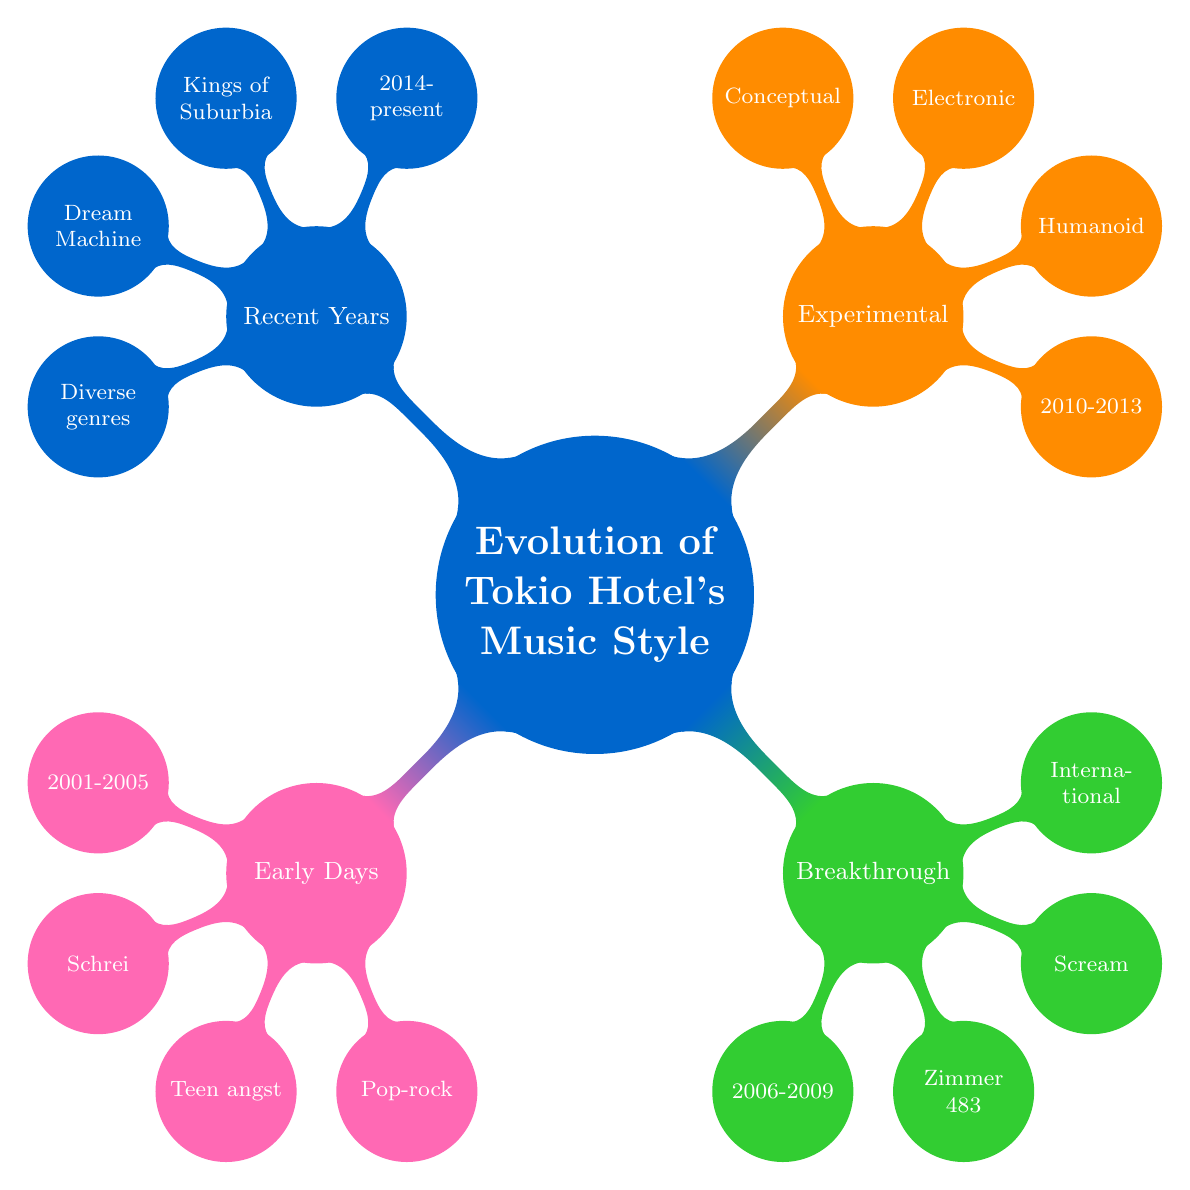What is the first key album listed in the Early Days? The diagram shows that the first key album under "Early Days" is represented directly beneath the node. It is clear from the visual structure that "Schrei" is indicated there.
Answer: Schrei What years encompass the Breakthrough Period? By examining the node corresponding to the "Breakthrough Period," we can see the years displayed beneath it. The information is explicitly shown in that position of the diagram.
Answer: 2006 - 2009 How many characteristics are listed for the Experimental Phase? The "Experimental Phase" node has multiple child nodes below it, each representing a characteristic. Counting these nodes gives us the total number of characteristics listed, which are four in this instance.
Answer: 4 Which album is associated with the Recent Years period? Looking at the "Recent Years" node, we can see multiple key albums listed underneath it. One of these albums is "Kings of Suburbia," which is one of the key albums for this time frame.
Answer: Kings of Suburbia What do the characteristics of the early days reflect? To answer this, we refer to the child nodes under the "Early Days" node. The words "Teen angst lyrics," "Pop-rock sound," and "Heavy guitar riffs" reflect the themes of that music style directly represented there. Therefore, the overall essence can be summarized accurately.
Answer: Teen angst lyrics Which music style features prominent themes in Recent Years? By analyzing the "Recent Years" node and its characteristics, we can observe that one of the characteristics emphasizes "Mature themes," which accurately depicts the lyrical content during this time.
Answer: Mature themes What color represents the Breakthrough Period? In the mind map, each node is distinctly colored, and "Breakthrough Period" is highlighted in green. Therefore, by simply identifying the color associated with that section, we arrive at the answer.
Answer: Green What transition can be seen in the musical influences from Early Days to Recent Years? To find this, we need to look at the characteristics of the "Early Days" and "Recent Years" nodes. The early days emphasize a "Pop-rock sound," while the recent years highlight "Global musical influences." This shows a significant transition from a more localized music style to a broader, diverse influence.
Answer: From Pop-rock to Global musical influences How many albums are listed under the Experimental Phase? The "Experimental Phase" node has one key album listed, which is "Humanoid." This is explicitly mentioned under that section, so counting the visible items shows there is only one.
Answer: 1 